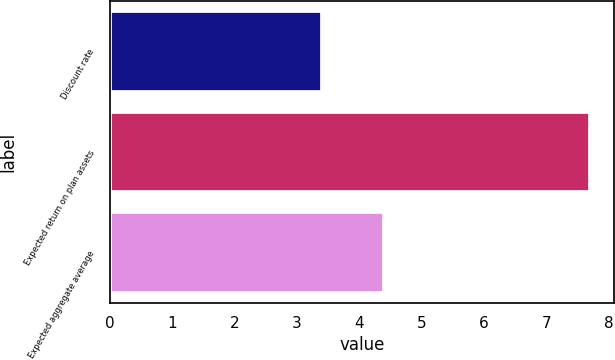Convert chart to OTSL. <chart><loc_0><loc_0><loc_500><loc_500><bar_chart><fcel>Discount rate<fcel>Expected return on plan assets<fcel>Expected aggregate average<nl><fcel>3.4<fcel>7.7<fcel>4.4<nl></chart> 